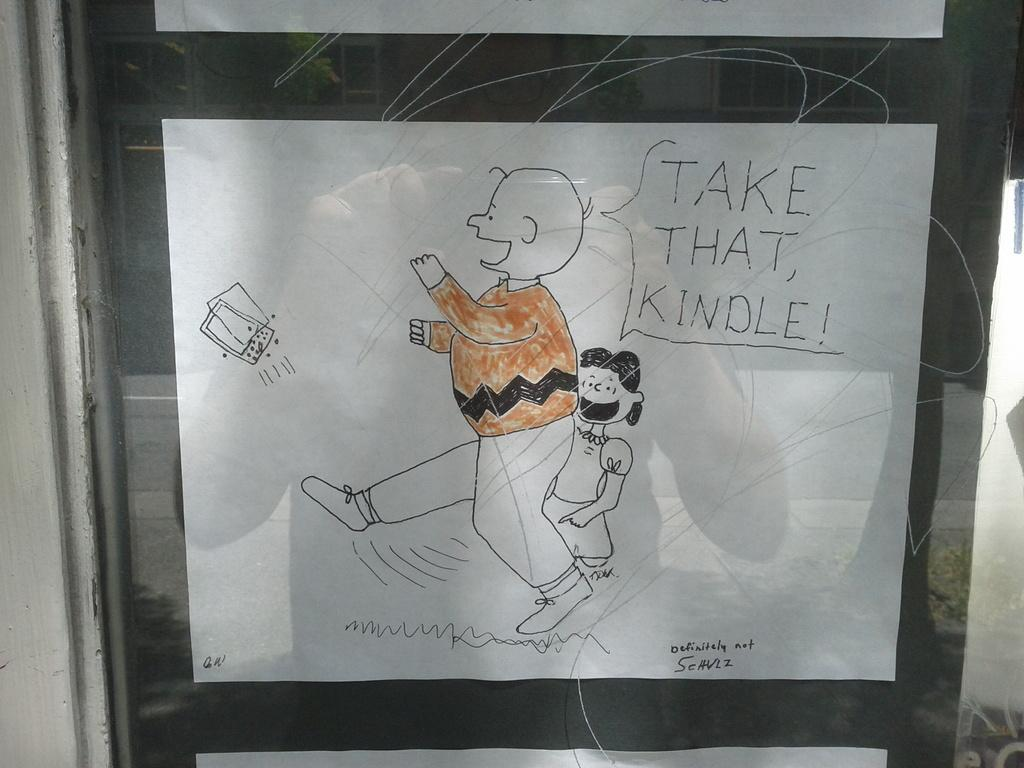What is the main object in the image? There is a white chart in the image. What is depicted on the white chart? There is a drawing on the chart. What is placed in front of the chart? There is a glass in front of the chart. What can be seen on the glass? There are lines on the glass. What color is the curtain behind the truck in the image? There is no truck or curtain present in the image. 